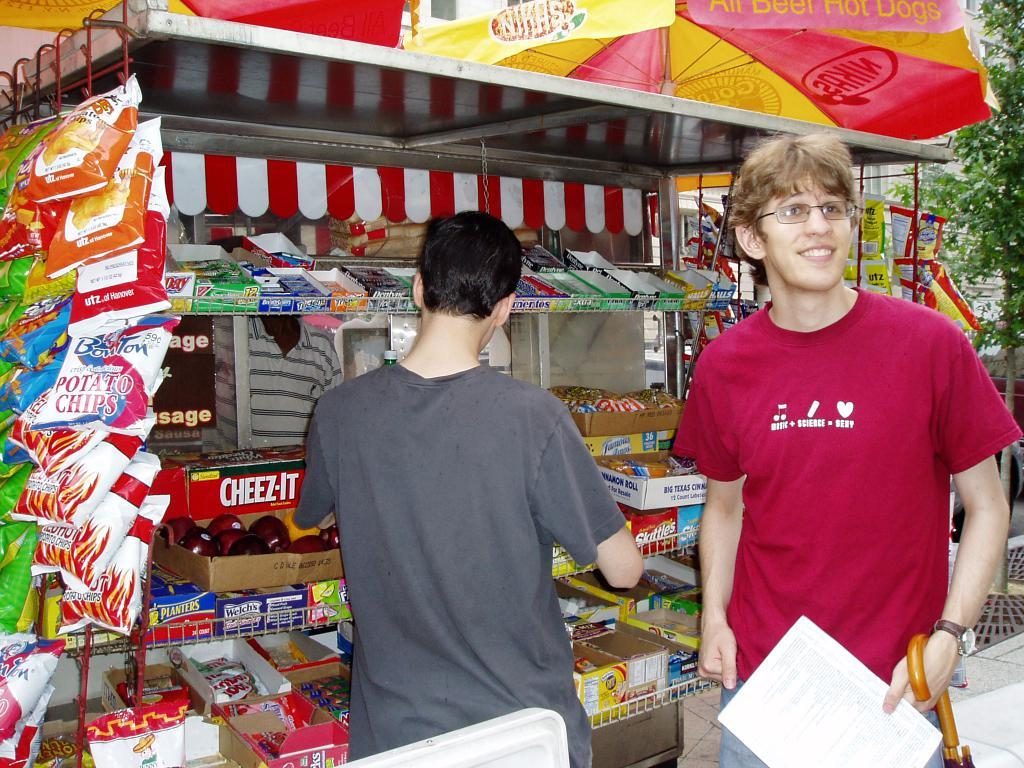Provide a one-sentence caption for the provided image. A snack stand selling snacks and Cheez-It and other snacks. 